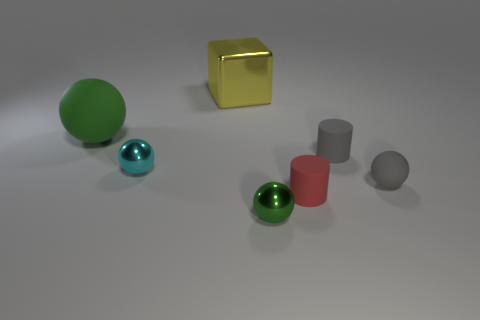Is there a large green matte object?
Ensure brevity in your answer.  Yes. There is a tiny ball that is the same material as the small gray cylinder; what color is it?
Offer a very short reply. Gray. The cylinder behind the tiny rubber cylinder in front of the tiny rubber thing that is to the right of the gray rubber cylinder is what color?
Offer a terse response. Gray. There is a cyan metallic thing; is it the same size as the rubber sphere to the right of the small green object?
Provide a short and direct response. Yes. What number of things are things in front of the gray cylinder or spheres that are left of the yellow metal thing?
Make the answer very short. 5. What is the shape of the green rubber thing that is the same size as the cube?
Provide a short and direct response. Sphere. There is a yellow thing on the left side of the tiny metallic ball on the right side of the small cyan ball in front of the metallic block; what shape is it?
Ensure brevity in your answer.  Cube. Are there the same number of big green balls that are left of the large yellow metal object and tiny cyan shiny spheres?
Your response must be concise. Yes. Is the size of the cyan object the same as the red matte cylinder?
Offer a very short reply. Yes. What number of shiny things are yellow balls or small spheres?
Offer a terse response. 2. 